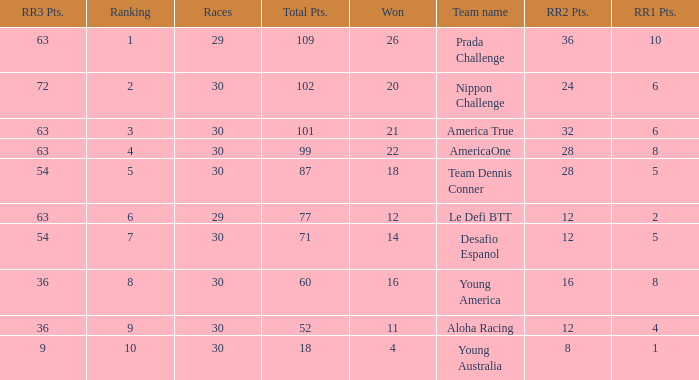Name the ranking for rr2 pts being 8 10.0. 